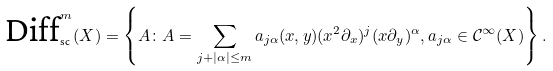<formula> <loc_0><loc_0><loc_500><loc_500>\text {Diff} _ { \text {sc} } ^ { m } ( X ) = \left \{ A \colon A = \sum _ { j + | \alpha | \leq m } a _ { j \alpha } ( x , y ) ( x ^ { 2 } \partial _ { x } ) ^ { j } ( x \partial _ { y } ) ^ { \alpha } , a _ { j \alpha } \in \mathcal { C } ^ { \infty } ( X ) \right \} .</formula> 